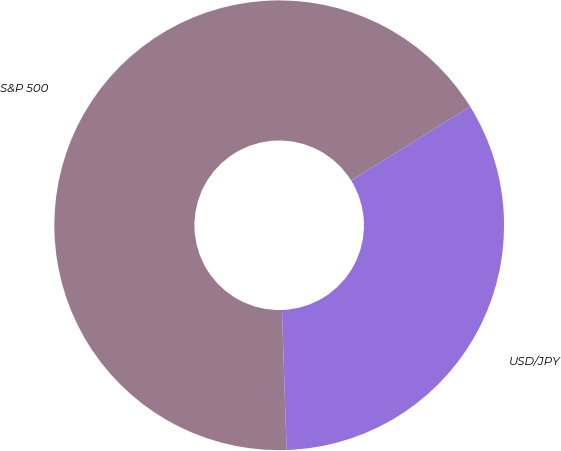Convert chart to OTSL. <chart><loc_0><loc_0><loc_500><loc_500><pie_chart><fcel>S&P 500<fcel>USD/JPY<nl><fcel>66.67%<fcel>33.33%<nl></chart> 